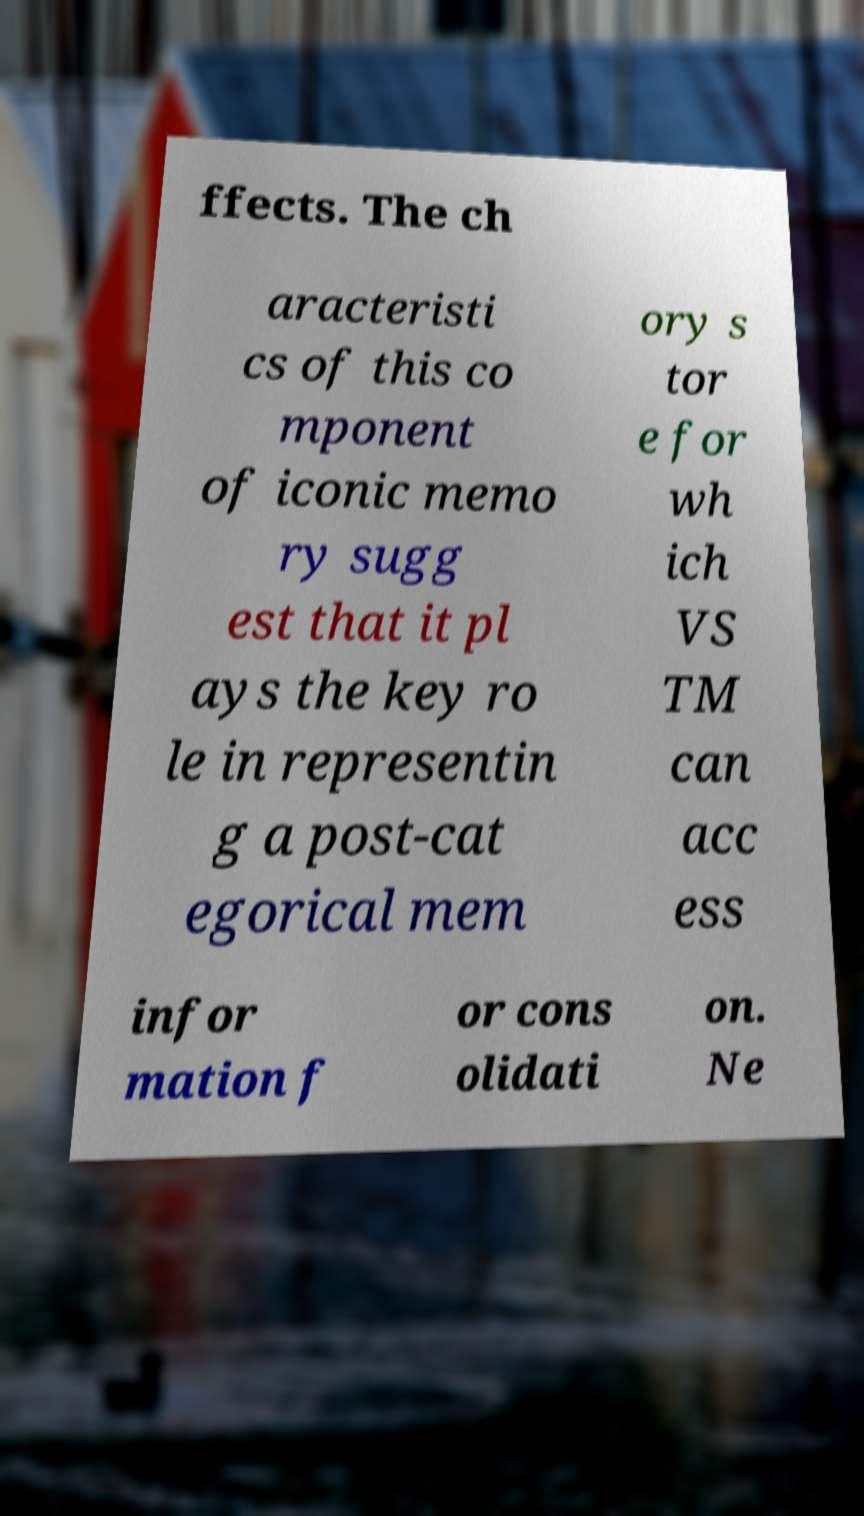Can you read and provide the text displayed in the image?This photo seems to have some interesting text. Can you extract and type it out for me? ffects. The ch aracteristi cs of this co mponent of iconic memo ry sugg est that it pl ays the key ro le in representin g a post-cat egorical mem ory s tor e for wh ich VS TM can acc ess infor mation f or cons olidati on. Ne 